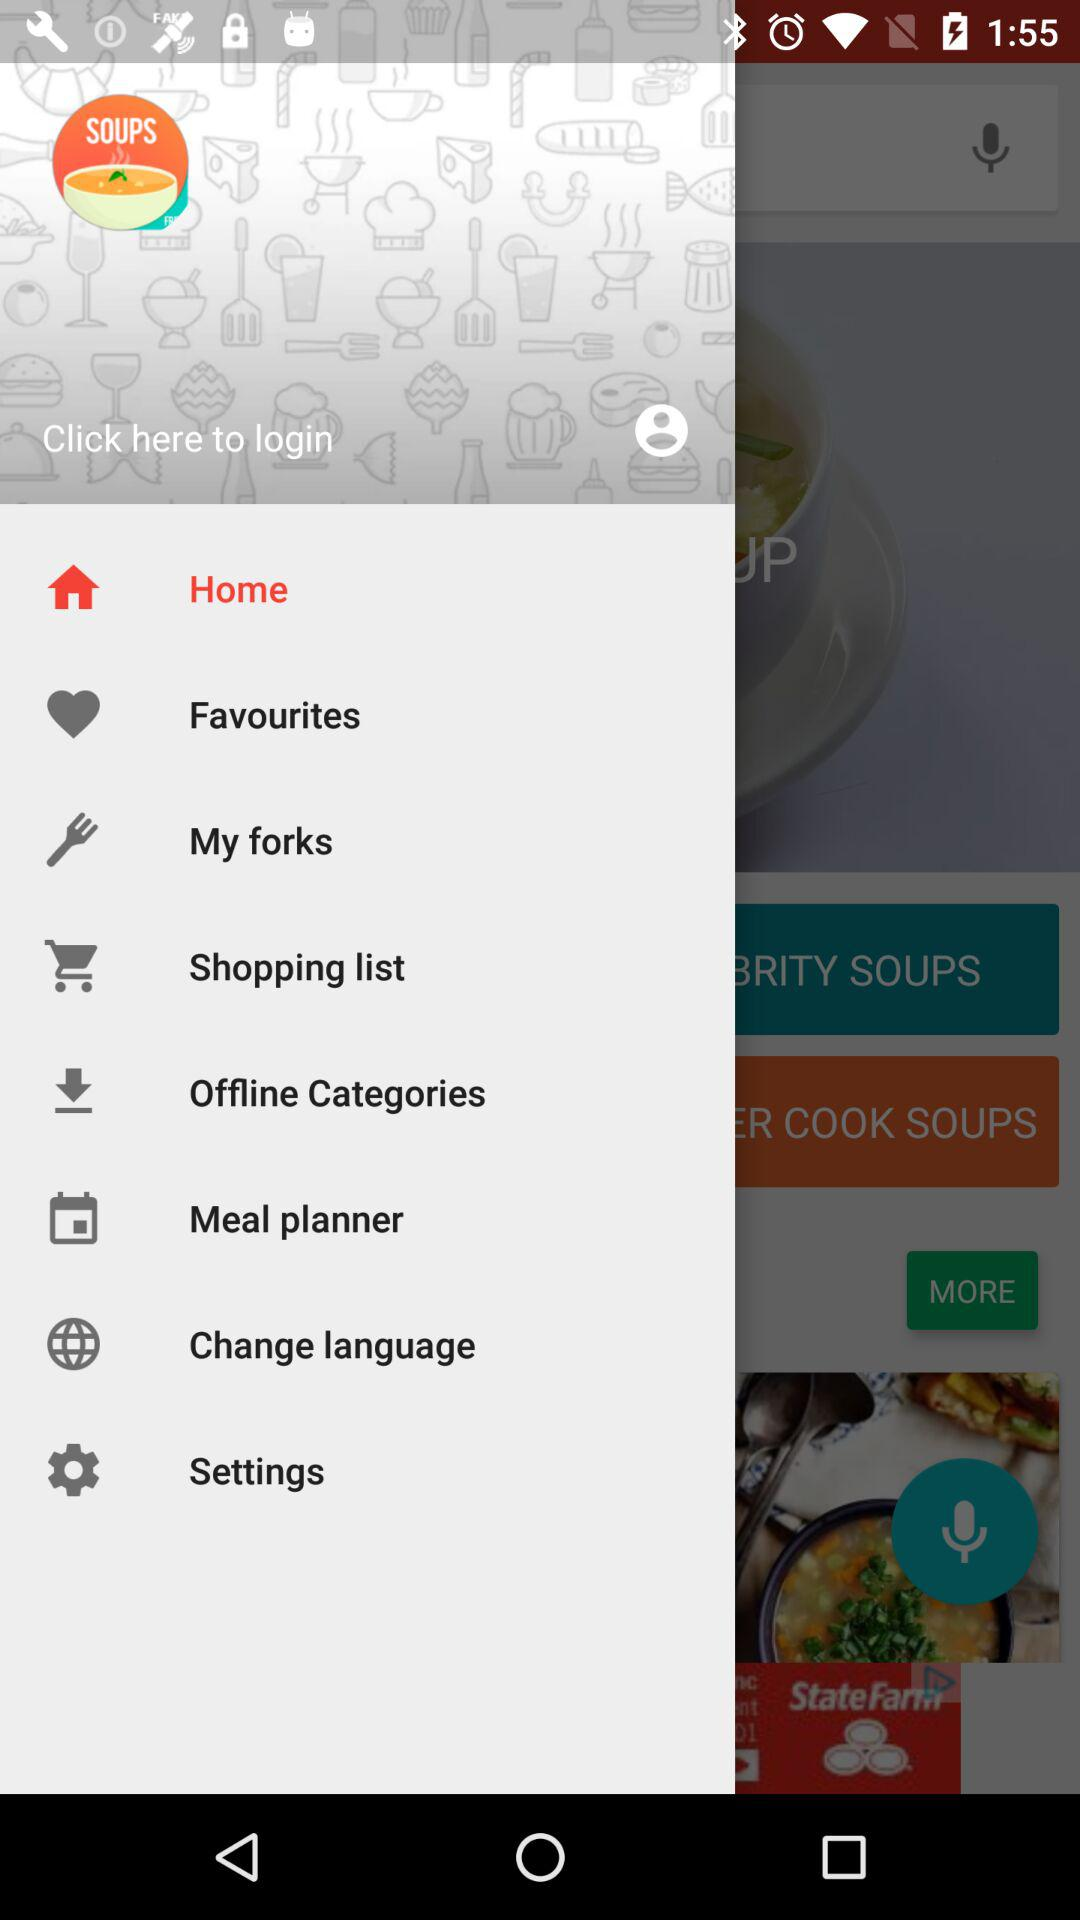Which item is selected? The item "Home" is selected. 